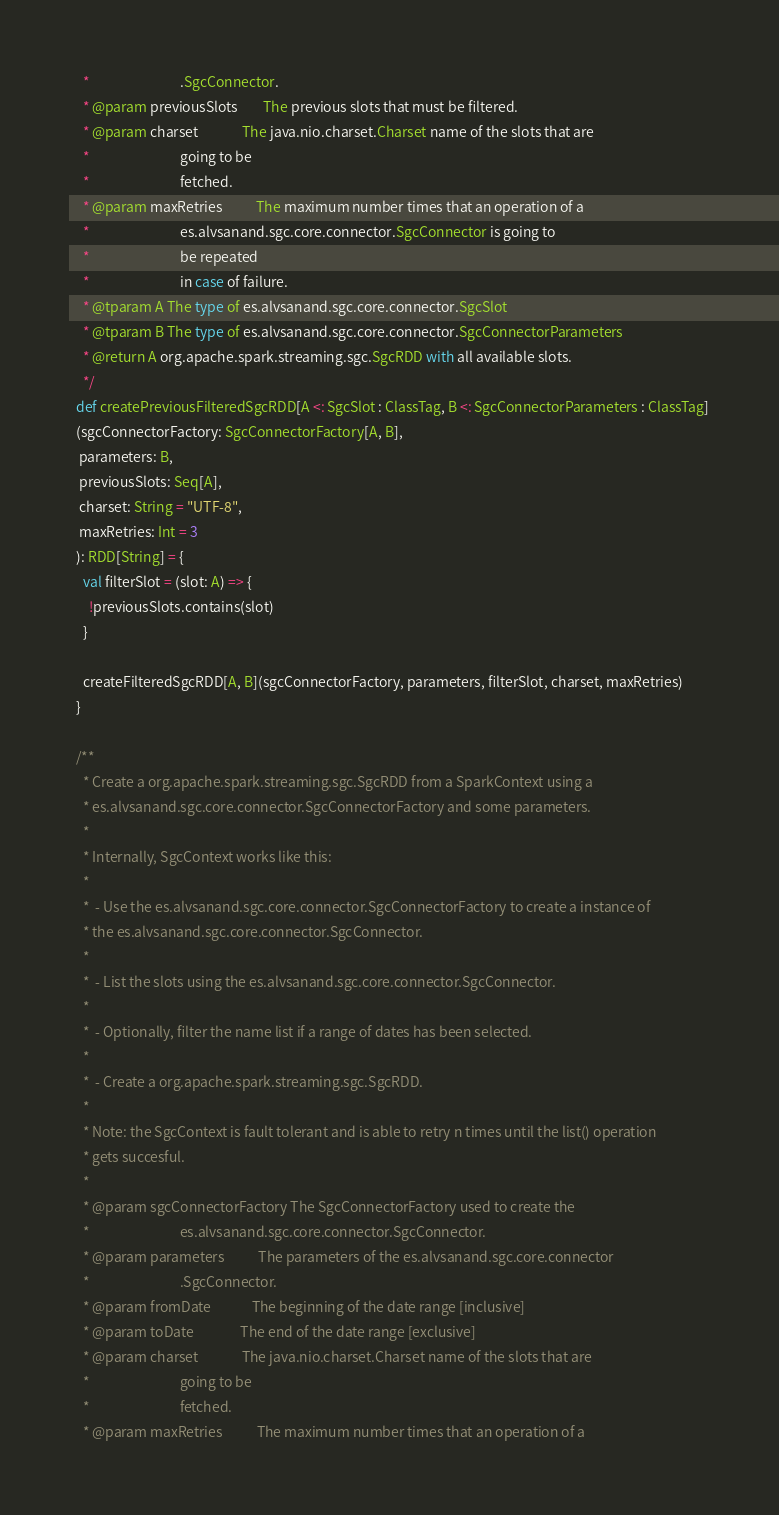<code> <loc_0><loc_0><loc_500><loc_500><_Scala_>    *                             .SgcConnector.
    * @param previousSlots        The previous slots that must be filtered.
    * @param charset              The java.nio.charset.Charset name of the slots that are
    *                             going to be
    *                             fetched.
    * @param maxRetries           The maximum number times that an operation of a
    *                             es.alvsanand.sgc.core.connector.SgcConnector is going to
    *                             be repeated
    *                             in case of failure.
    * @tparam A The type of es.alvsanand.sgc.core.connector.SgcSlot
    * @tparam B The type of es.alvsanand.sgc.core.connector.SgcConnectorParameters
    * @return A org.apache.spark.streaming.sgc.SgcRDD with all available slots.
    */
  def createPreviousFilteredSgcRDD[A <: SgcSlot : ClassTag, B <: SgcConnectorParameters : ClassTag]
  (sgcConnectorFactory: SgcConnectorFactory[A, B],
   parameters: B,
   previousSlots: Seq[A],
   charset: String = "UTF-8",
   maxRetries: Int = 3
  ): RDD[String] = {
    val filterSlot = (slot: A) => {
      !previousSlots.contains(slot)
    }

    createFilteredSgcRDD[A, B](sgcConnectorFactory, parameters, filterSlot, charset, maxRetries)
  }

  /**
    * Create a org.apache.spark.streaming.sgc.SgcRDD from a SparkContext using a
    * es.alvsanand.sgc.core.connector.SgcConnectorFactory and some parameters.
    *
    * Internally, SgcContext works like this:
    *
    *  - Use the es.alvsanand.sgc.core.connector.SgcConnectorFactory to create a instance of
    * the es.alvsanand.sgc.core.connector.SgcConnector.
    *
    *  - List the slots using the es.alvsanand.sgc.core.connector.SgcConnector.
    *
    *  - Optionally, filter the name list if a range of dates has been selected.
    *
    *  - Create a org.apache.spark.streaming.sgc.SgcRDD.
    *
    * Note: the SgcContext is fault tolerant and is able to retry n times until the list() operation
    * gets succesful.
    *
    * @param sgcConnectorFactory The SgcConnectorFactory used to create the
    *                             es.alvsanand.sgc.core.connector.SgcConnector.
    * @param parameters           The parameters of the es.alvsanand.sgc.core.connector
    *                             .SgcConnector.
    * @param fromDate             The beginning of the date range [inclusive]
    * @param toDate               The end of the date range [exclusive]
    * @param charset              The java.nio.charset.Charset name of the slots that are
    *                             going to be
    *                             fetched.
    * @param maxRetries           The maximum number times that an operation of a</code> 